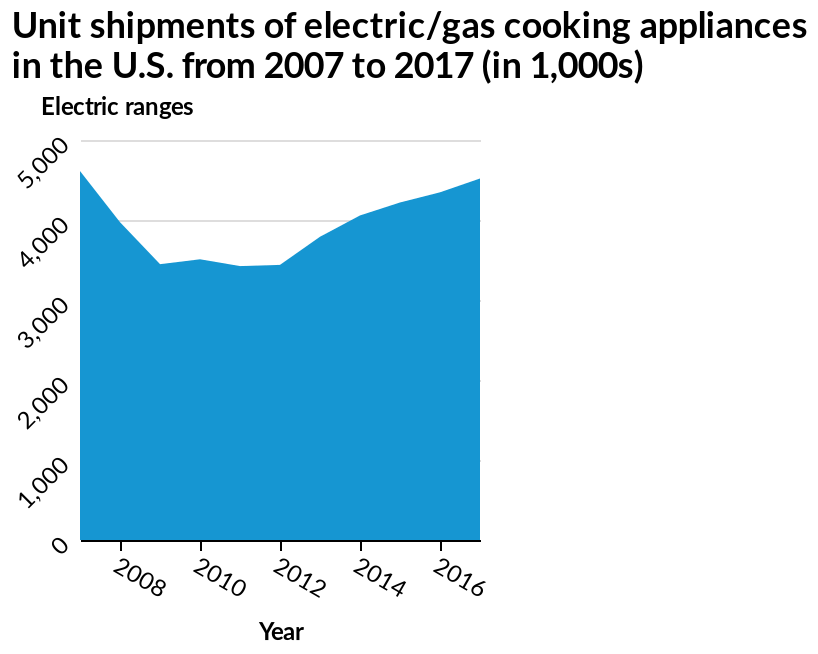<image>
What happened to the sales of appliances in the US after 2013? After 2013, there was another rise in sales which continued until 2016. Was there any significant change in sales of appliances in the US between 2007 and 2009?  Yes, there was a sharp dip in sales between 2007 and 2009. What is plotted on the x-axis of the area diagram? The x-axis of the area diagram plots the years from 2007 to 2017. 